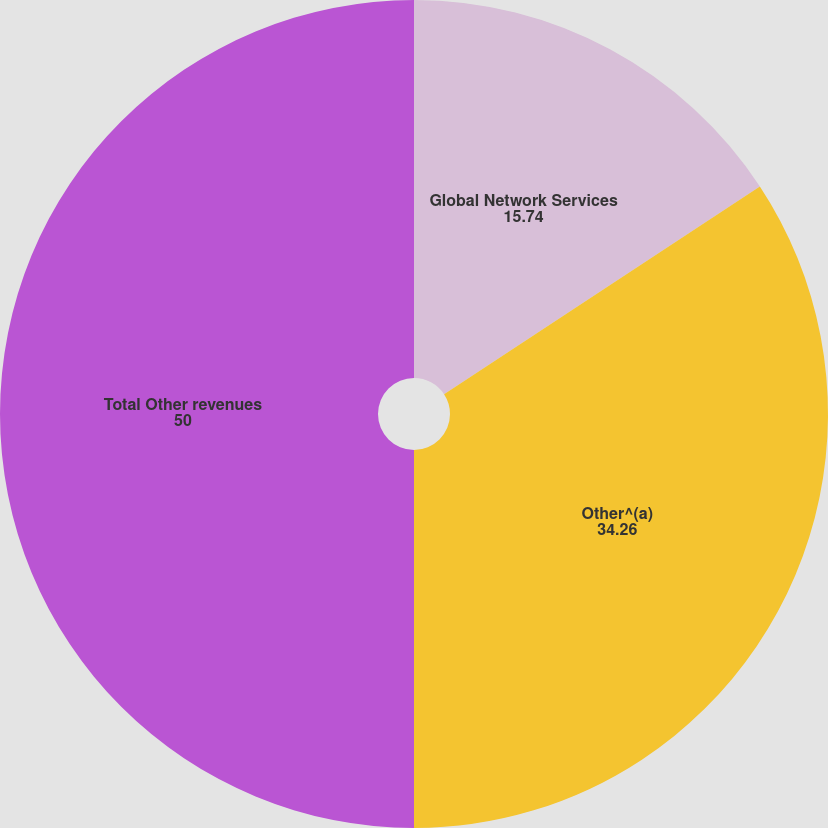Convert chart. <chart><loc_0><loc_0><loc_500><loc_500><pie_chart><fcel>Global Network Services<fcel>Other^(a)<fcel>Total Other revenues<nl><fcel>15.74%<fcel>34.26%<fcel>50.0%<nl></chart> 